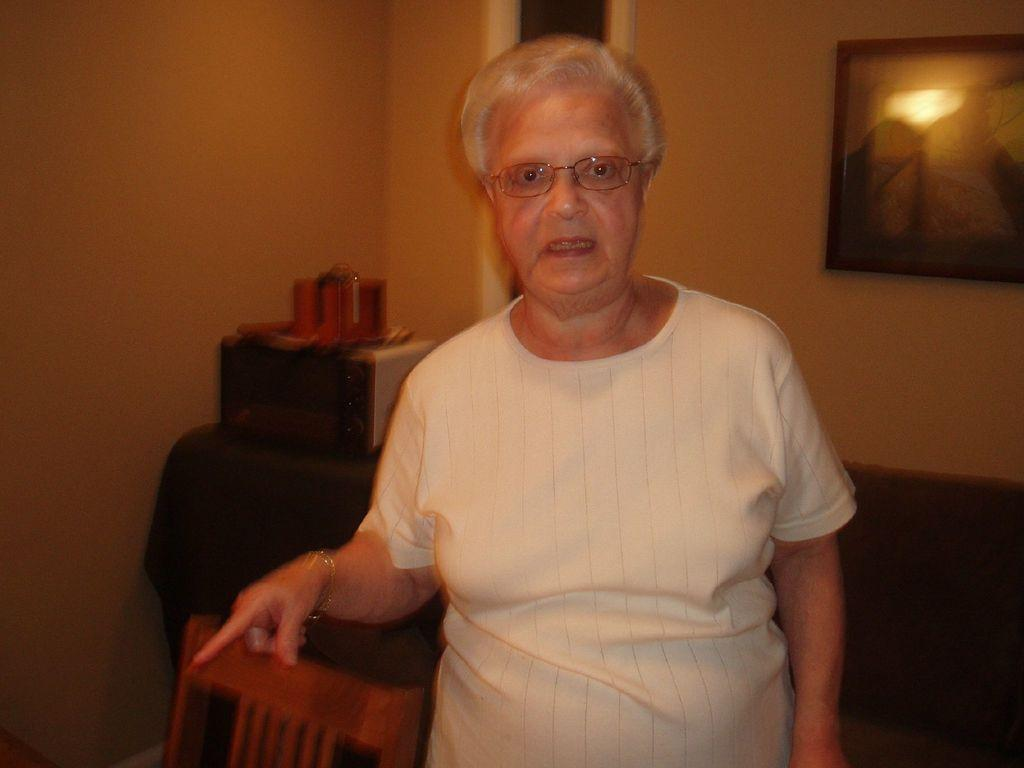Who is present in the image? There is a woman in the image. What is the woman doing? The woman is talking. What can be seen behind the woman? There is an oven behind the woman. What is visible in the background of the image? There is a wall in the background of the image. Can you describe the wall in the image? There is a photo frame attached to the wall. What type of map can be seen on the wall in the image? There is no map present on the wall in the image; it has a photo frame instead. 